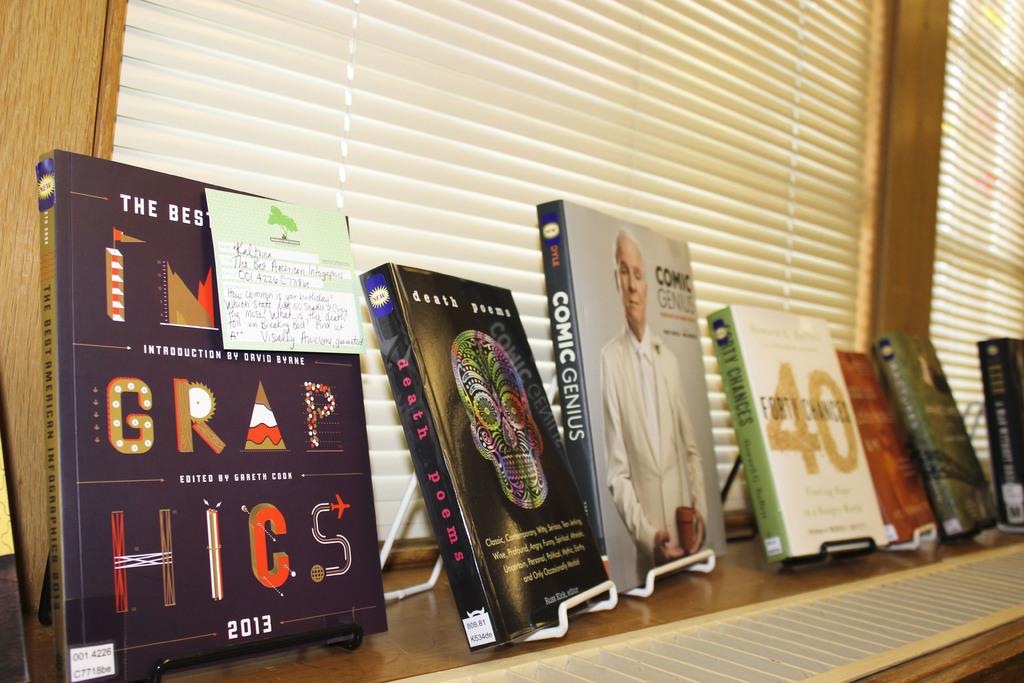What is the year that is printed on the book to the far left?
Provide a succinct answer. 2013. According to the book, steve martin is what?
Give a very brief answer. Comic genius. 